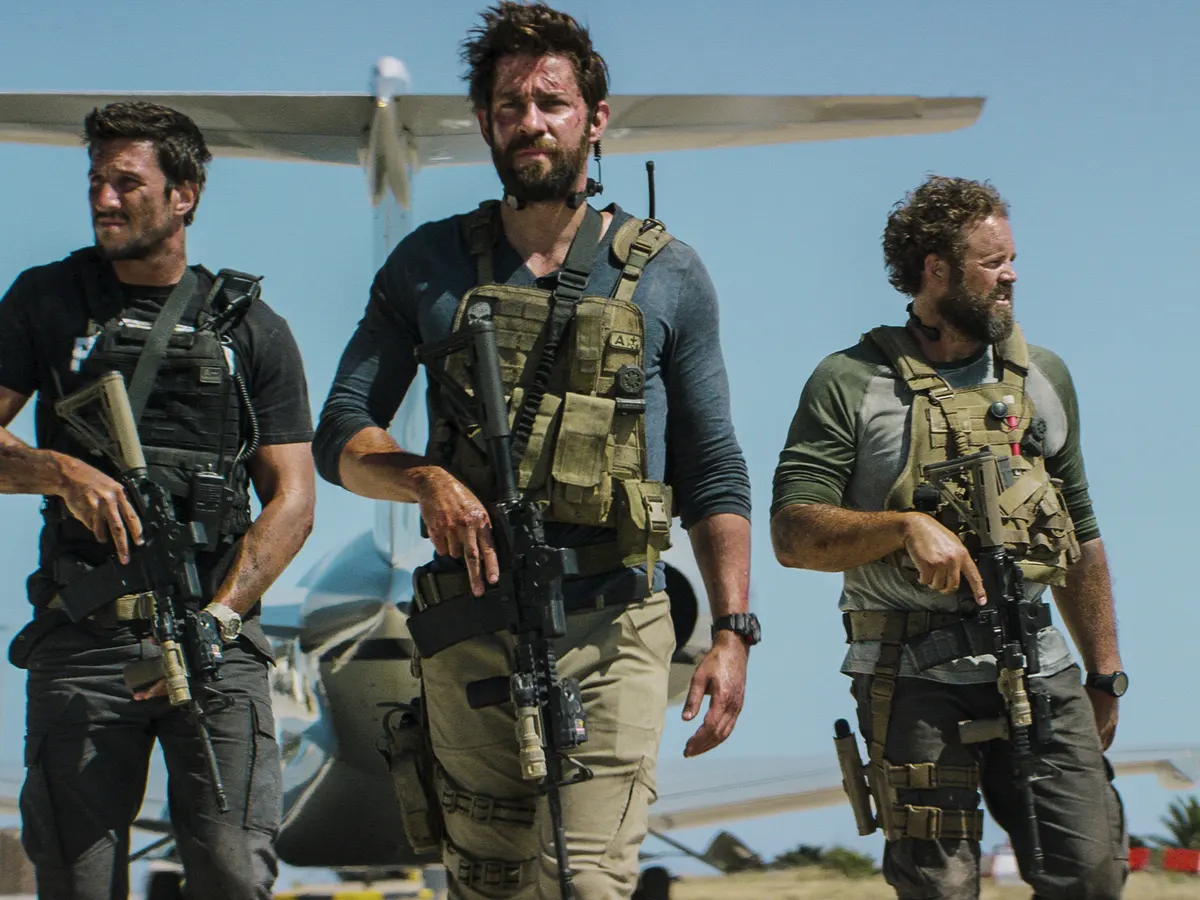What kind of mission do you think these men are on? The men appear to be on a military or special ops mission. Their tactical gear, serious expressions, and the presence of rifles suggest they are preparing for a high-stakes operation, possibly in a hostile or dangerous environment. The small aircraft in the background hints at a recent arrival or a planned extraction point, indicating that their mission might involve reconnaissance, rescue, or a direct engagement with threats. What do you think their goal is in this mission? Given the intense and focused expressions on their faces, it is likely that their goal is critical and time-sensitive. They might be aiming to secure a strategic location, gather vital intelligence, or extract a high-profile individual to safety. The presence of advanced tactical equipment suggests a well-coordinated effort, implying they are highly trained professionals working towards a specific objective. Imagine if the location was not just a desert. What other environments could add exciting twists to this scene? Imagine if instead of a desert, this scene was taking place in a dense, fog-covered forest, with the shadows of trees creating a maze-like environment. The men would have to maneuver silently, with heightened senses to avoid detection. Alternatively, consider an urban environment, a city at night with abandoned skyscrapers and alleyways, their mission becoming a cat-and-mouse game under the flickering streetlights. Or, envision a tropical jungle, the humid air thick with the sounds of wildlife, and the team navigating through foliage and muddy terrain, adding an element of survival against both nature and potential adversaries. 